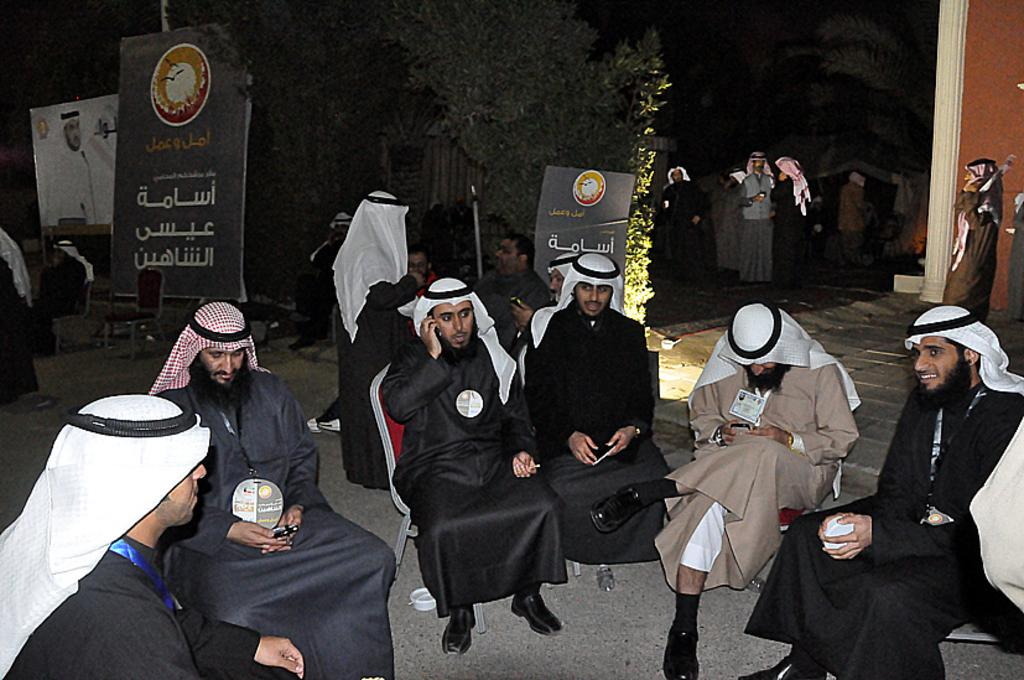What is the position of the people in the image? There is a group of people on the ground, and some people are sitting on chairs. What can be seen in the background of the image? There are trees, posters, and other objects visible in the background of the image. What type of corn is being harvested in the image? There is no corn present in the image; it features a group of people and objects in the background. 